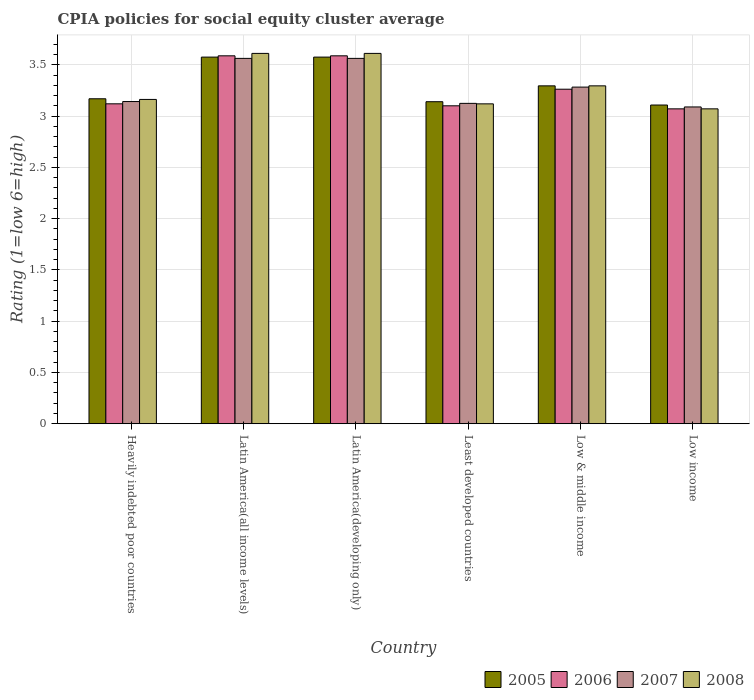How many groups of bars are there?
Keep it short and to the point. 6. Are the number of bars per tick equal to the number of legend labels?
Your answer should be compact. Yes. Are the number of bars on each tick of the X-axis equal?
Offer a very short reply. Yes. How many bars are there on the 5th tick from the right?
Offer a terse response. 4. What is the label of the 1st group of bars from the left?
Your answer should be very brief. Heavily indebted poor countries. What is the CPIA rating in 2006 in Latin America(developing only)?
Ensure brevity in your answer.  3.59. Across all countries, what is the maximum CPIA rating in 2005?
Give a very brief answer. 3.58. Across all countries, what is the minimum CPIA rating in 2007?
Make the answer very short. 3.09. In which country was the CPIA rating in 2005 maximum?
Keep it short and to the point. Latin America(all income levels). In which country was the CPIA rating in 2007 minimum?
Give a very brief answer. Low income. What is the total CPIA rating in 2008 in the graph?
Your response must be concise. 19.87. What is the difference between the CPIA rating in 2006 in Latin America(developing only) and that in Low income?
Keep it short and to the point. 0.52. What is the difference between the CPIA rating in 2008 in Least developed countries and the CPIA rating in 2007 in Low income?
Make the answer very short. 0.03. What is the average CPIA rating in 2005 per country?
Ensure brevity in your answer.  3.31. What is the difference between the CPIA rating of/in 2008 and CPIA rating of/in 2006 in Low income?
Offer a terse response. 0. In how many countries, is the CPIA rating in 2006 greater than 3.3?
Provide a succinct answer. 2. What is the ratio of the CPIA rating in 2007 in Latin America(developing only) to that in Low income?
Provide a short and direct response. 1.15. Is the CPIA rating in 2005 in Latin America(all income levels) less than that in Least developed countries?
Offer a very short reply. No. What is the difference between the highest and the second highest CPIA rating in 2006?
Offer a terse response. -0.33. What is the difference between the highest and the lowest CPIA rating in 2008?
Provide a succinct answer. 0.54. In how many countries, is the CPIA rating in 2008 greater than the average CPIA rating in 2008 taken over all countries?
Provide a short and direct response. 2. What does the 4th bar from the left in Heavily indebted poor countries represents?
Offer a very short reply. 2008. What does the 1st bar from the right in Latin America(developing only) represents?
Provide a succinct answer. 2008. Is it the case that in every country, the sum of the CPIA rating in 2006 and CPIA rating in 2008 is greater than the CPIA rating in 2007?
Your answer should be compact. Yes. How many bars are there?
Give a very brief answer. 24. How many countries are there in the graph?
Make the answer very short. 6. Are the values on the major ticks of Y-axis written in scientific E-notation?
Make the answer very short. No. Does the graph contain any zero values?
Provide a succinct answer. No. How many legend labels are there?
Offer a terse response. 4. What is the title of the graph?
Provide a succinct answer. CPIA policies for social equity cluster average. What is the label or title of the X-axis?
Ensure brevity in your answer.  Country. What is the Rating (1=low 6=high) in 2005 in Heavily indebted poor countries?
Keep it short and to the point. 3.17. What is the Rating (1=low 6=high) of 2006 in Heavily indebted poor countries?
Ensure brevity in your answer.  3.12. What is the Rating (1=low 6=high) of 2007 in Heavily indebted poor countries?
Make the answer very short. 3.14. What is the Rating (1=low 6=high) of 2008 in Heavily indebted poor countries?
Offer a very short reply. 3.16. What is the Rating (1=low 6=high) in 2005 in Latin America(all income levels)?
Your response must be concise. 3.58. What is the Rating (1=low 6=high) in 2006 in Latin America(all income levels)?
Provide a succinct answer. 3.59. What is the Rating (1=low 6=high) of 2007 in Latin America(all income levels)?
Your answer should be compact. 3.56. What is the Rating (1=low 6=high) of 2008 in Latin America(all income levels)?
Your response must be concise. 3.61. What is the Rating (1=low 6=high) of 2005 in Latin America(developing only)?
Provide a succinct answer. 3.58. What is the Rating (1=low 6=high) in 2006 in Latin America(developing only)?
Give a very brief answer. 3.59. What is the Rating (1=low 6=high) in 2007 in Latin America(developing only)?
Make the answer very short. 3.56. What is the Rating (1=low 6=high) in 2008 in Latin America(developing only)?
Offer a terse response. 3.61. What is the Rating (1=low 6=high) of 2005 in Least developed countries?
Provide a short and direct response. 3.14. What is the Rating (1=low 6=high) of 2006 in Least developed countries?
Provide a short and direct response. 3.1. What is the Rating (1=low 6=high) of 2007 in Least developed countries?
Your answer should be compact. 3.12. What is the Rating (1=low 6=high) of 2008 in Least developed countries?
Your answer should be compact. 3.12. What is the Rating (1=low 6=high) of 2005 in Low & middle income?
Your answer should be very brief. 3.29. What is the Rating (1=low 6=high) of 2006 in Low & middle income?
Give a very brief answer. 3.26. What is the Rating (1=low 6=high) in 2007 in Low & middle income?
Give a very brief answer. 3.28. What is the Rating (1=low 6=high) of 2008 in Low & middle income?
Keep it short and to the point. 3.29. What is the Rating (1=low 6=high) in 2005 in Low income?
Keep it short and to the point. 3.11. What is the Rating (1=low 6=high) of 2006 in Low income?
Provide a succinct answer. 3.07. What is the Rating (1=low 6=high) of 2007 in Low income?
Provide a succinct answer. 3.09. What is the Rating (1=low 6=high) in 2008 in Low income?
Make the answer very short. 3.07. Across all countries, what is the maximum Rating (1=low 6=high) in 2005?
Keep it short and to the point. 3.58. Across all countries, what is the maximum Rating (1=low 6=high) in 2006?
Keep it short and to the point. 3.59. Across all countries, what is the maximum Rating (1=low 6=high) in 2007?
Give a very brief answer. 3.56. Across all countries, what is the maximum Rating (1=low 6=high) of 2008?
Provide a succinct answer. 3.61. Across all countries, what is the minimum Rating (1=low 6=high) of 2005?
Your response must be concise. 3.11. Across all countries, what is the minimum Rating (1=low 6=high) in 2006?
Offer a very short reply. 3.07. Across all countries, what is the minimum Rating (1=low 6=high) in 2007?
Give a very brief answer. 3.09. Across all countries, what is the minimum Rating (1=low 6=high) of 2008?
Give a very brief answer. 3.07. What is the total Rating (1=low 6=high) in 2005 in the graph?
Your answer should be compact. 19.86. What is the total Rating (1=low 6=high) in 2006 in the graph?
Provide a succinct answer. 19.73. What is the total Rating (1=low 6=high) of 2007 in the graph?
Your answer should be compact. 19.76. What is the total Rating (1=low 6=high) in 2008 in the graph?
Your answer should be very brief. 19.87. What is the difference between the Rating (1=low 6=high) of 2005 in Heavily indebted poor countries and that in Latin America(all income levels)?
Ensure brevity in your answer.  -0.41. What is the difference between the Rating (1=low 6=high) of 2006 in Heavily indebted poor countries and that in Latin America(all income levels)?
Your response must be concise. -0.47. What is the difference between the Rating (1=low 6=high) in 2007 in Heavily indebted poor countries and that in Latin America(all income levels)?
Your answer should be compact. -0.42. What is the difference between the Rating (1=low 6=high) in 2008 in Heavily indebted poor countries and that in Latin America(all income levels)?
Give a very brief answer. -0.45. What is the difference between the Rating (1=low 6=high) of 2005 in Heavily indebted poor countries and that in Latin America(developing only)?
Make the answer very short. -0.41. What is the difference between the Rating (1=low 6=high) in 2006 in Heavily indebted poor countries and that in Latin America(developing only)?
Your answer should be compact. -0.47. What is the difference between the Rating (1=low 6=high) of 2007 in Heavily indebted poor countries and that in Latin America(developing only)?
Your answer should be very brief. -0.42. What is the difference between the Rating (1=low 6=high) of 2008 in Heavily indebted poor countries and that in Latin America(developing only)?
Your response must be concise. -0.45. What is the difference between the Rating (1=low 6=high) in 2005 in Heavily indebted poor countries and that in Least developed countries?
Provide a short and direct response. 0.03. What is the difference between the Rating (1=low 6=high) in 2006 in Heavily indebted poor countries and that in Least developed countries?
Provide a succinct answer. 0.02. What is the difference between the Rating (1=low 6=high) in 2007 in Heavily indebted poor countries and that in Least developed countries?
Keep it short and to the point. 0.02. What is the difference between the Rating (1=low 6=high) in 2008 in Heavily indebted poor countries and that in Least developed countries?
Provide a succinct answer. 0.04. What is the difference between the Rating (1=low 6=high) in 2005 in Heavily indebted poor countries and that in Low & middle income?
Give a very brief answer. -0.13. What is the difference between the Rating (1=low 6=high) of 2006 in Heavily indebted poor countries and that in Low & middle income?
Make the answer very short. -0.14. What is the difference between the Rating (1=low 6=high) in 2007 in Heavily indebted poor countries and that in Low & middle income?
Your answer should be very brief. -0.14. What is the difference between the Rating (1=low 6=high) of 2008 in Heavily indebted poor countries and that in Low & middle income?
Give a very brief answer. -0.13. What is the difference between the Rating (1=low 6=high) in 2005 in Heavily indebted poor countries and that in Low income?
Your response must be concise. 0.06. What is the difference between the Rating (1=low 6=high) of 2006 in Heavily indebted poor countries and that in Low income?
Make the answer very short. 0.05. What is the difference between the Rating (1=low 6=high) in 2007 in Heavily indebted poor countries and that in Low income?
Provide a succinct answer. 0.05. What is the difference between the Rating (1=low 6=high) of 2008 in Heavily indebted poor countries and that in Low income?
Keep it short and to the point. 0.09. What is the difference between the Rating (1=low 6=high) of 2005 in Latin America(all income levels) and that in Latin America(developing only)?
Provide a short and direct response. 0. What is the difference between the Rating (1=low 6=high) in 2005 in Latin America(all income levels) and that in Least developed countries?
Give a very brief answer. 0.43. What is the difference between the Rating (1=low 6=high) of 2006 in Latin America(all income levels) and that in Least developed countries?
Your answer should be very brief. 0.49. What is the difference between the Rating (1=low 6=high) in 2007 in Latin America(all income levels) and that in Least developed countries?
Your response must be concise. 0.44. What is the difference between the Rating (1=low 6=high) of 2008 in Latin America(all income levels) and that in Least developed countries?
Make the answer very short. 0.49. What is the difference between the Rating (1=low 6=high) of 2005 in Latin America(all income levels) and that in Low & middle income?
Provide a short and direct response. 0.28. What is the difference between the Rating (1=low 6=high) in 2006 in Latin America(all income levels) and that in Low & middle income?
Provide a succinct answer. 0.33. What is the difference between the Rating (1=low 6=high) of 2007 in Latin America(all income levels) and that in Low & middle income?
Your answer should be very brief. 0.28. What is the difference between the Rating (1=low 6=high) in 2008 in Latin America(all income levels) and that in Low & middle income?
Provide a succinct answer. 0.32. What is the difference between the Rating (1=low 6=high) of 2005 in Latin America(all income levels) and that in Low income?
Offer a very short reply. 0.47. What is the difference between the Rating (1=low 6=high) of 2006 in Latin America(all income levels) and that in Low income?
Give a very brief answer. 0.52. What is the difference between the Rating (1=low 6=high) of 2007 in Latin America(all income levels) and that in Low income?
Your answer should be very brief. 0.47. What is the difference between the Rating (1=low 6=high) in 2008 in Latin America(all income levels) and that in Low income?
Offer a very short reply. 0.54. What is the difference between the Rating (1=low 6=high) of 2005 in Latin America(developing only) and that in Least developed countries?
Offer a very short reply. 0.43. What is the difference between the Rating (1=low 6=high) in 2006 in Latin America(developing only) and that in Least developed countries?
Your response must be concise. 0.49. What is the difference between the Rating (1=low 6=high) of 2007 in Latin America(developing only) and that in Least developed countries?
Keep it short and to the point. 0.44. What is the difference between the Rating (1=low 6=high) in 2008 in Latin America(developing only) and that in Least developed countries?
Offer a very short reply. 0.49. What is the difference between the Rating (1=low 6=high) in 2005 in Latin America(developing only) and that in Low & middle income?
Provide a short and direct response. 0.28. What is the difference between the Rating (1=low 6=high) in 2006 in Latin America(developing only) and that in Low & middle income?
Give a very brief answer. 0.33. What is the difference between the Rating (1=low 6=high) in 2007 in Latin America(developing only) and that in Low & middle income?
Give a very brief answer. 0.28. What is the difference between the Rating (1=low 6=high) in 2008 in Latin America(developing only) and that in Low & middle income?
Your response must be concise. 0.32. What is the difference between the Rating (1=low 6=high) of 2005 in Latin America(developing only) and that in Low income?
Provide a succinct answer. 0.47. What is the difference between the Rating (1=low 6=high) of 2006 in Latin America(developing only) and that in Low income?
Your response must be concise. 0.52. What is the difference between the Rating (1=low 6=high) of 2007 in Latin America(developing only) and that in Low income?
Ensure brevity in your answer.  0.47. What is the difference between the Rating (1=low 6=high) in 2008 in Latin America(developing only) and that in Low income?
Provide a succinct answer. 0.54. What is the difference between the Rating (1=low 6=high) of 2005 in Least developed countries and that in Low & middle income?
Your response must be concise. -0.15. What is the difference between the Rating (1=low 6=high) of 2006 in Least developed countries and that in Low & middle income?
Your answer should be compact. -0.16. What is the difference between the Rating (1=low 6=high) in 2007 in Least developed countries and that in Low & middle income?
Provide a succinct answer. -0.16. What is the difference between the Rating (1=low 6=high) in 2008 in Least developed countries and that in Low & middle income?
Give a very brief answer. -0.18. What is the difference between the Rating (1=low 6=high) of 2005 in Least developed countries and that in Low income?
Offer a terse response. 0.03. What is the difference between the Rating (1=low 6=high) of 2006 in Least developed countries and that in Low income?
Keep it short and to the point. 0.03. What is the difference between the Rating (1=low 6=high) of 2007 in Least developed countries and that in Low income?
Your response must be concise. 0.03. What is the difference between the Rating (1=low 6=high) in 2008 in Least developed countries and that in Low income?
Your answer should be very brief. 0.05. What is the difference between the Rating (1=low 6=high) of 2005 in Low & middle income and that in Low income?
Offer a terse response. 0.19. What is the difference between the Rating (1=low 6=high) in 2006 in Low & middle income and that in Low income?
Provide a succinct answer. 0.19. What is the difference between the Rating (1=low 6=high) in 2007 in Low & middle income and that in Low income?
Make the answer very short. 0.19. What is the difference between the Rating (1=low 6=high) of 2008 in Low & middle income and that in Low income?
Make the answer very short. 0.22. What is the difference between the Rating (1=low 6=high) in 2005 in Heavily indebted poor countries and the Rating (1=low 6=high) in 2006 in Latin America(all income levels)?
Your answer should be compact. -0.42. What is the difference between the Rating (1=low 6=high) in 2005 in Heavily indebted poor countries and the Rating (1=low 6=high) in 2007 in Latin America(all income levels)?
Your response must be concise. -0.39. What is the difference between the Rating (1=low 6=high) of 2005 in Heavily indebted poor countries and the Rating (1=low 6=high) of 2008 in Latin America(all income levels)?
Your answer should be compact. -0.44. What is the difference between the Rating (1=low 6=high) in 2006 in Heavily indebted poor countries and the Rating (1=low 6=high) in 2007 in Latin America(all income levels)?
Give a very brief answer. -0.44. What is the difference between the Rating (1=low 6=high) in 2006 in Heavily indebted poor countries and the Rating (1=low 6=high) in 2008 in Latin America(all income levels)?
Give a very brief answer. -0.49. What is the difference between the Rating (1=low 6=high) in 2007 in Heavily indebted poor countries and the Rating (1=low 6=high) in 2008 in Latin America(all income levels)?
Ensure brevity in your answer.  -0.47. What is the difference between the Rating (1=low 6=high) in 2005 in Heavily indebted poor countries and the Rating (1=low 6=high) in 2006 in Latin America(developing only)?
Offer a very short reply. -0.42. What is the difference between the Rating (1=low 6=high) of 2005 in Heavily indebted poor countries and the Rating (1=low 6=high) of 2007 in Latin America(developing only)?
Give a very brief answer. -0.39. What is the difference between the Rating (1=low 6=high) of 2005 in Heavily indebted poor countries and the Rating (1=low 6=high) of 2008 in Latin America(developing only)?
Keep it short and to the point. -0.44. What is the difference between the Rating (1=low 6=high) of 2006 in Heavily indebted poor countries and the Rating (1=low 6=high) of 2007 in Latin America(developing only)?
Offer a very short reply. -0.44. What is the difference between the Rating (1=low 6=high) of 2006 in Heavily indebted poor countries and the Rating (1=low 6=high) of 2008 in Latin America(developing only)?
Ensure brevity in your answer.  -0.49. What is the difference between the Rating (1=low 6=high) in 2007 in Heavily indebted poor countries and the Rating (1=low 6=high) in 2008 in Latin America(developing only)?
Keep it short and to the point. -0.47. What is the difference between the Rating (1=low 6=high) in 2005 in Heavily indebted poor countries and the Rating (1=low 6=high) in 2006 in Least developed countries?
Provide a succinct answer. 0.07. What is the difference between the Rating (1=low 6=high) in 2005 in Heavily indebted poor countries and the Rating (1=low 6=high) in 2007 in Least developed countries?
Make the answer very short. 0.04. What is the difference between the Rating (1=low 6=high) in 2005 in Heavily indebted poor countries and the Rating (1=low 6=high) in 2008 in Least developed countries?
Provide a succinct answer. 0.05. What is the difference between the Rating (1=low 6=high) of 2006 in Heavily indebted poor countries and the Rating (1=low 6=high) of 2007 in Least developed countries?
Ensure brevity in your answer.  -0. What is the difference between the Rating (1=low 6=high) in 2006 in Heavily indebted poor countries and the Rating (1=low 6=high) in 2008 in Least developed countries?
Your answer should be compact. 0. What is the difference between the Rating (1=low 6=high) in 2007 in Heavily indebted poor countries and the Rating (1=low 6=high) in 2008 in Least developed countries?
Make the answer very short. 0.02. What is the difference between the Rating (1=low 6=high) in 2005 in Heavily indebted poor countries and the Rating (1=low 6=high) in 2006 in Low & middle income?
Offer a very short reply. -0.09. What is the difference between the Rating (1=low 6=high) in 2005 in Heavily indebted poor countries and the Rating (1=low 6=high) in 2007 in Low & middle income?
Give a very brief answer. -0.11. What is the difference between the Rating (1=low 6=high) of 2005 in Heavily indebted poor countries and the Rating (1=low 6=high) of 2008 in Low & middle income?
Your answer should be compact. -0.13. What is the difference between the Rating (1=low 6=high) in 2006 in Heavily indebted poor countries and the Rating (1=low 6=high) in 2007 in Low & middle income?
Give a very brief answer. -0.16. What is the difference between the Rating (1=low 6=high) of 2006 in Heavily indebted poor countries and the Rating (1=low 6=high) of 2008 in Low & middle income?
Provide a succinct answer. -0.18. What is the difference between the Rating (1=low 6=high) in 2007 in Heavily indebted poor countries and the Rating (1=low 6=high) in 2008 in Low & middle income?
Make the answer very short. -0.15. What is the difference between the Rating (1=low 6=high) of 2005 in Heavily indebted poor countries and the Rating (1=low 6=high) of 2006 in Low income?
Your answer should be very brief. 0.1. What is the difference between the Rating (1=low 6=high) in 2005 in Heavily indebted poor countries and the Rating (1=low 6=high) in 2007 in Low income?
Your answer should be very brief. 0.08. What is the difference between the Rating (1=low 6=high) in 2005 in Heavily indebted poor countries and the Rating (1=low 6=high) in 2008 in Low income?
Your answer should be compact. 0.1. What is the difference between the Rating (1=low 6=high) of 2006 in Heavily indebted poor countries and the Rating (1=low 6=high) of 2007 in Low income?
Provide a succinct answer. 0.03. What is the difference between the Rating (1=low 6=high) of 2006 in Heavily indebted poor countries and the Rating (1=low 6=high) of 2008 in Low income?
Your answer should be compact. 0.05. What is the difference between the Rating (1=low 6=high) in 2007 in Heavily indebted poor countries and the Rating (1=low 6=high) in 2008 in Low income?
Your response must be concise. 0.07. What is the difference between the Rating (1=low 6=high) in 2005 in Latin America(all income levels) and the Rating (1=low 6=high) in 2006 in Latin America(developing only)?
Your response must be concise. -0.01. What is the difference between the Rating (1=low 6=high) of 2005 in Latin America(all income levels) and the Rating (1=low 6=high) of 2007 in Latin America(developing only)?
Offer a terse response. 0.01. What is the difference between the Rating (1=low 6=high) of 2005 in Latin America(all income levels) and the Rating (1=low 6=high) of 2008 in Latin America(developing only)?
Offer a very short reply. -0.04. What is the difference between the Rating (1=low 6=high) of 2006 in Latin America(all income levels) and the Rating (1=low 6=high) of 2007 in Latin America(developing only)?
Give a very brief answer. 0.03. What is the difference between the Rating (1=low 6=high) in 2006 in Latin America(all income levels) and the Rating (1=low 6=high) in 2008 in Latin America(developing only)?
Your answer should be very brief. -0.02. What is the difference between the Rating (1=low 6=high) of 2007 in Latin America(all income levels) and the Rating (1=low 6=high) of 2008 in Latin America(developing only)?
Ensure brevity in your answer.  -0.05. What is the difference between the Rating (1=low 6=high) of 2005 in Latin America(all income levels) and the Rating (1=low 6=high) of 2006 in Least developed countries?
Provide a short and direct response. 0.47. What is the difference between the Rating (1=low 6=high) in 2005 in Latin America(all income levels) and the Rating (1=low 6=high) in 2007 in Least developed countries?
Keep it short and to the point. 0.45. What is the difference between the Rating (1=low 6=high) of 2005 in Latin America(all income levels) and the Rating (1=low 6=high) of 2008 in Least developed countries?
Ensure brevity in your answer.  0.46. What is the difference between the Rating (1=low 6=high) of 2006 in Latin America(all income levels) and the Rating (1=low 6=high) of 2007 in Least developed countries?
Give a very brief answer. 0.46. What is the difference between the Rating (1=low 6=high) in 2006 in Latin America(all income levels) and the Rating (1=low 6=high) in 2008 in Least developed countries?
Provide a succinct answer. 0.47. What is the difference between the Rating (1=low 6=high) in 2007 in Latin America(all income levels) and the Rating (1=low 6=high) in 2008 in Least developed countries?
Keep it short and to the point. 0.44. What is the difference between the Rating (1=low 6=high) of 2005 in Latin America(all income levels) and the Rating (1=low 6=high) of 2006 in Low & middle income?
Your answer should be very brief. 0.31. What is the difference between the Rating (1=low 6=high) in 2005 in Latin America(all income levels) and the Rating (1=low 6=high) in 2007 in Low & middle income?
Ensure brevity in your answer.  0.29. What is the difference between the Rating (1=low 6=high) in 2005 in Latin America(all income levels) and the Rating (1=low 6=high) in 2008 in Low & middle income?
Offer a terse response. 0.28. What is the difference between the Rating (1=low 6=high) in 2006 in Latin America(all income levels) and the Rating (1=low 6=high) in 2007 in Low & middle income?
Make the answer very short. 0.31. What is the difference between the Rating (1=low 6=high) of 2006 in Latin America(all income levels) and the Rating (1=low 6=high) of 2008 in Low & middle income?
Ensure brevity in your answer.  0.29. What is the difference between the Rating (1=low 6=high) of 2007 in Latin America(all income levels) and the Rating (1=low 6=high) of 2008 in Low & middle income?
Ensure brevity in your answer.  0.27. What is the difference between the Rating (1=low 6=high) in 2005 in Latin America(all income levels) and the Rating (1=low 6=high) in 2006 in Low income?
Offer a very short reply. 0.5. What is the difference between the Rating (1=low 6=high) in 2005 in Latin America(all income levels) and the Rating (1=low 6=high) in 2007 in Low income?
Your answer should be very brief. 0.49. What is the difference between the Rating (1=low 6=high) of 2005 in Latin America(all income levels) and the Rating (1=low 6=high) of 2008 in Low income?
Your answer should be compact. 0.5. What is the difference between the Rating (1=low 6=high) of 2006 in Latin America(all income levels) and the Rating (1=low 6=high) of 2007 in Low income?
Offer a very short reply. 0.5. What is the difference between the Rating (1=low 6=high) of 2006 in Latin America(all income levels) and the Rating (1=low 6=high) of 2008 in Low income?
Your response must be concise. 0.52. What is the difference between the Rating (1=low 6=high) of 2007 in Latin America(all income levels) and the Rating (1=low 6=high) of 2008 in Low income?
Provide a succinct answer. 0.49. What is the difference between the Rating (1=low 6=high) of 2005 in Latin America(developing only) and the Rating (1=low 6=high) of 2006 in Least developed countries?
Provide a succinct answer. 0.47. What is the difference between the Rating (1=low 6=high) of 2005 in Latin America(developing only) and the Rating (1=low 6=high) of 2007 in Least developed countries?
Provide a short and direct response. 0.45. What is the difference between the Rating (1=low 6=high) in 2005 in Latin America(developing only) and the Rating (1=low 6=high) in 2008 in Least developed countries?
Provide a short and direct response. 0.46. What is the difference between the Rating (1=low 6=high) of 2006 in Latin America(developing only) and the Rating (1=low 6=high) of 2007 in Least developed countries?
Make the answer very short. 0.46. What is the difference between the Rating (1=low 6=high) of 2006 in Latin America(developing only) and the Rating (1=low 6=high) of 2008 in Least developed countries?
Provide a short and direct response. 0.47. What is the difference between the Rating (1=low 6=high) in 2007 in Latin America(developing only) and the Rating (1=low 6=high) in 2008 in Least developed countries?
Offer a terse response. 0.44. What is the difference between the Rating (1=low 6=high) of 2005 in Latin America(developing only) and the Rating (1=low 6=high) of 2006 in Low & middle income?
Your answer should be compact. 0.31. What is the difference between the Rating (1=low 6=high) of 2005 in Latin America(developing only) and the Rating (1=low 6=high) of 2007 in Low & middle income?
Your response must be concise. 0.29. What is the difference between the Rating (1=low 6=high) in 2005 in Latin America(developing only) and the Rating (1=low 6=high) in 2008 in Low & middle income?
Give a very brief answer. 0.28. What is the difference between the Rating (1=low 6=high) in 2006 in Latin America(developing only) and the Rating (1=low 6=high) in 2007 in Low & middle income?
Give a very brief answer. 0.31. What is the difference between the Rating (1=low 6=high) in 2006 in Latin America(developing only) and the Rating (1=low 6=high) in 2008 in Low & middle income?
Your response must be concise. 0.29. What is the difference between the Rating (1=low 6=high) in 2007 in Latin America(developing only) and the Rating (1=low 6=high) in 2008 in Low & middle income?
Offer a terse response. 0.27. What is the difference between the Rating (1=low 6=high) of 2005 in Latin America(developing only) and the Rating (1=low 6=high) of 2006 in Low income?
Provide a short and direct response. 0.5. What is the difference between the Rating (1=low 6=high) of 2005 in Latin America(developing only) and the Rating (1=low 6=high) of 2007 in Low income?
Give a very brief answer. 0.49. What is the difference between the Rating (1=low 6=high) in 2005 in Latin America(developing only) and the Rating (1=low 6=high) in 2008 in Low income?
Offer a very short reply. 0.5. What is the difference between the Rating (1=low 6=high) of 2006 in Latin America(developing only) and the Rating (1=low 6=high) of 2007 in Low income?
Give a very brief answer. 0.5. What is the difference between the Rating (1=low 6=high) in 2006 in Latin America(developing only) and the Rating (1=low 6=high) in 2008 in Low income?
Provide a short and direct response. 0.52. What is the difference between the Rating (1=low 6=high) in 2007 in Latin America(developing only) and the Rating (1=low 6=high) in 2008 in Low income?
Provide a short and direct response. 0.49. What is the difference between the Rating (1=low 6=high) in 2005 in Least developed countries and the Rating (1=low 6=high) in 2006 in Low & middle income?
Your answer should be compact. -0.12. What is the difference between the Rating (1=low 6=high) in 2005 in Least developed countries and the Rating (1=low 6=high) in 2007 in Low & middle income?
Offer a very short reply. -0.14. What is the difference between the Rating (1=low 6=high) in 2005 in Least developed countries and the Rating (1=low 6=high) in 2008 in Low & middle income?
Give a very brief answer. -0.15. What is the difference between the Rating (1=low 6=high) of 2006 in Least developed countries and the Rating (1=low 6=high) of 2007 in Low & middle income?
Give a very brief answer. -0.18. What is the difference between the Rating (1=low 6=high) in 2006 in Least developed countries and the Rating (1=low 6=high) in 2008 in Low & middle income?
Offer a terse response. -0.19. What is the difference between the Rating (1=low 6=high) of 2007 in Least developed countries and the Rating (1=low 6=high) of 2008 in Low & middle income?
Give a very brief answer. -0.17. What is the difference between the Rating (1=low 6=high) in 2005 in Least developed countries and the Rating (1=low 6=high) in 2006 in Low income?
Offer a terse response. 0.07. What is the difference between the Rating (1=low 6=high) in 2005 in Least developed countries and the Rating (1=low 6=high) in 2007 in Low income?
Provide a short and direct response. 0.05. What is the difference between the Rating (1=low 6=high) of 2005 in Least developed countries and the Rating (1=low 6=high) of 2008 in Low income?
Offer a terse response. 0.07. What is the difference between the Rating (1=low 6=high) in 2006 in Least developed countries and the Rating (1=low 6=high) in 2007 in Low income?
Keep it short and to the point. 0.01. What is the difference between the Rating (1=low 6=high) in 2006 in Least developed countries and the Rating (1=low 6=high) in 2008 in Low income?
Your answer should be compact. 0.03. What is the difference between the Rating (1=low 6=high) in 2007 in Least developed countries and the Rating (1=low 6=high) in 2008 in Low income?
Offer a very short reply. 0.05. What is the difference between the Rating (1=low 6=high) of 2005 in Low & middle income and the Rating (1=low 6=high) of 2006 in Low income?
Your response must be concise. 0.22. What is the difference between the Rating (1=low 6=high) in 2005 in Low & middle income and the Rating (1=low 6=high) in 2007 in Low income?
Give a very brief answer. 0.21. What is the difference between the Rating (1=low 6=high) in 2005 in Low & middle income and the Rating (1=low 6=high) in 2008 in Low income?
Provide a succinct answer. 0.22. What is the difference between the Rating (1=low 6=high) in 2006 in Low & middle income and the Rating (1=low 6=high) in 2007 in Low income?
Make the answer very short. 0.17. What is the difference between the Rating (1=low 6=high) in 2006 in Low & middle income and the Rating (1=low 6=high) in 2008 in Low income?
Your answer should be compact. 0.19. What is the difference between the Rating (1=low 6=high) of 2007 in Low & middle income and the Rating (1=low 6=high) of 2008 in Low income?
Provide a succinct answer. 0.21. What is the average Rating (1=low 6=high) in 2005 per country?
Your answer should be very brief. 3.31. What is the average Rating (1=low 6=high) in 2006 per country?
Your answer should be very brief. 3.29. What is the average Rating (1=low 6=high) of 2007 per country?
Ensure brevity in your answer.  3.29. What is the average Rating (1=low 6=high) of 2008 per country?
Offer a terse response. 3.31. What is the difference between the Rating (1=low 6=high) in 2005 and Rating (1=low 6=high) in 2006 in Heavily indebted poor countries?
Your response must be concise. 0.05. What is the difference between the Rating (1=low 6=high) in 2005 and Rating (1=low 6=high) in 2007 in Heavily indebted poor countries?
Offer a terse response. 0.03. What is the difference between the Rating (1=low 6=high) in 2005 and Rating (1=low 6=high) in 2008 in Heavily indebted poor countries?
Ensure brevity in your answer.  0.01. What is the difference between the Rating (1=low 6=high) in 2006 and Rating (1=low 6=high) in 2007 in Heavily indebted poor countries?
Your answer should be compact. -0.02. What is the difference between the Rating (1=low 6=high) of 2006 and Rating (1=low 6=high) of 2008 in Heavily indebted poor countries?
Offer a terse response. -0.04. What is the difference between the Rating (1=low 6=high) in 2007 and Rating (1=low 6=high) in 2008 in Heavily indebted poor countries?
Your answer should be very brief. -0.02. What is the difference between the Rating (1=low 6=high) in 2005 and Rating (1=low 6=high) in 2006 in Latin America(all income levels)?
Give a very brief answer. -0.01. What is the difference between the Rating (1=low 6=high) of 2005 and Rating (1=low 6=high) of 2007 in Latin America(all income levels)?
Keep it short and to the point. 0.01. What is the difference between the Rating (1=low 6=high) in 2005 and Rating (1=low 6=high) in 2008 in Latin America(all income levels)?
Offer a terse response. -0.04. What is the difference between the Rating (1=low 6=high) of 2006 and Rating (1=low 6=high) of 2007 in Latin America(all income levels)?
Keep it short and to the point. 0.03. What is the difference between the Rating (1=low 6=high) of 2006 and Rating (1=low 6=high) of 2008 in Latin America(all income levels)?
Provide a succinct answer. -0.02. What is the difference between the Rating (1=low 6=high) in 2007 and Rating (1=low 6=high) in 2008 in Latin America(all income levels)?
Your answer should be very brief. -0.05. What is the difference between the Rating (1=low 6=high) of 2005 and Rating (1=low 6=high) of 2006 in Latin America(developing only)?
Provide a short and direct response. -0.01. What is the difference between the Rating (1=low 6=high) in 2005 and Rating (1=low 6=high) in 2007 in Latin America(developing only)?
Your response must be concise. 0.01. What is the difference between the Rating (1=low 6=high) of 2005 and Rating (1=low 6=high) of 2008 in Latin America(developing only)?
Offer a very short reply. -0.04. What is the difference between the Rating (1=low 6=high) in 2006 and Rating (1=low 6=high) in 2007 in Latin America(developing only)?
Your response must be concise. 0.03. What is the difference between the Rating (1=low 6=high) of 2006 and Rating (1=low 6=high) of 2008 in Latin America(developing only)?
Your answer should be compact. -0.02. What is the difference between the Rating (1=low 6=high) in 2007 and Rating (1=low 6=high) in 2008 in Latin America(developing only)?
Ensure brevity in your answer.  -0.05. What is the difference between the Rating (1=low 6=high) of 2005 and Rating (1=low 6=high) of 2007 in Least developed countries?
Offer a terse response. 0.02. What is the difference between the Rating (1=low 6=high) of 2005 and Rating (1=low 6=high) of 2008 in Least developed countries?
Provide a short and direct response. 0.02. What is the difference between the Rating (1=low 6=high) of 2006 and Rating (1=low 6=high) of 2007 in Least developed countries?
Your response must be concise. -0.02. What is the difference between the Rating (1=low 6=high) of 2006 and Rating (1=low 6=high) of 2008 in Least developed countries?
Offer a very short reply. -0.02. What is the difference between the Rating (1=low 6=high) of 2007 and Rating (1=low 6=high) of 2008 in Least developed countries?
Offer a very short reply. 0. What is the difference between the Rating (1=low 6=high) of 2005 and Rating (1=low 6=high) of 2006 in Low & middle income?
Your answer should be very brief. 0.03. What is the difference between the Rating (1=low 6=high) in 2005 and Rating (1=low 6=high) in 2007 in Low & middle income?
Ensure brevity in your answer.  0.01. What is the difference between the Rating (1=low 6=high) in 2005 and Rating (1=low 6=high) in 2008 in Low & middle income?
Offer a very short reply. -0. What is the difference between the Rating (1=low 6=high) in 2006 and Rating (1=low 6=high) in 2007 in Low & middle income?
Offer a terse response. -0.02. What is the difference between the Rating (1=low 6=high) in 2006 and Rating (1=low 6=high) in 2008 in Low & middle income?
Your response must be concise. -0.03. What is the difference between the Rating (1=low 6=high) of 2007 and Rating (1=low 6=high) of 2008 in Low & middle income?
Make the answer very short. -0.01. What is the difference between the Rating (1=low 6=high) of 2005 and Rating (1=low 6=high) of 2006 in Low income?
Your response must be concise. 0.04. What is the difference between the Rating (1=low 6=high) of 2005 and Rating (1=low 6=high) of 2007 in Low income?
Offer a terse response. 0.02. What is the difference between the Rating (1=low 6=high) of 2005 and Rating (1=low 6=high) of 2008 in Low income?
Your answer should be very brief. 0.04. What is the difference between the Rating (1=low 6=high) in 2006 and Rating (1=low 6=high) in 2007 in Low income?
Your answer should be very brief. -0.02. What is the difference between the Rating (1=low 6=high) of 2007 and Rating (1=low 6=high) of 2008 in Low income?
Your answer should be very brief. 0.02. What is the ratio of the Rating (1=low 6=high) of 2005 in Heavily indebted poor countries to that in Latin America(all income levels)?
Ensure brevity in your answer.  0.89. What is the ratio of the Rating (1=low 6=high) of 2006 in Heavily indebted poor countries to that in Latin America(all income levels)?
Keep it short and to the point. 0.87. What is the ratio of the Rating (1=low 6=high) in 2007 in Heavily indebted poor countries to that in Latin America(all income levels)?
Offer a very short reply. 0.88. What is the ratio of the Rating (1=low 6=high) of 2008 in Heavily indebted poor countries to that in Latin America(all income levels)?
Make the answer very short. 0.88. What is the ratio of the Rating (1=low 6=high) in 2005 in Heavily indebted poor countries to that in Latin America(developing only)?
Your response must be concise. 0.89. What is the ratio of the Rating (1=low 6=high) in 2006 in Heavily indebted poor countries to that in Latin America(developing only)?
Your response must be concise. 0.87. What is the ratio of the Rating (1=low 6=high) in 2007 in Heavily indebted poor countries to that in Latin America(developing only)?
Provide a succinct answer. 0.88. What is the ratio of the Rating (1=low 6=high) of 2008 in Heavily indebted poor countries to that in Latin America(developing only)?
Make the answer very short. 0.88. What is the ratio of the Rating (1=low 6=high) in 2005 in Heavily indebted poor countries to that in Least developed countries?
Your response must be concise. 1.01. What is the ratio of the Rating (1=low 6=high) in 2006 in Heavily indebted poor countries to that in Least developed countries?
Offer a terse response. 1.01. What is the ratio of the Rating (1=low 6=high) of 2007 in Heavily indebted poor countries to that in Least developed countries?
Ensure brevity in your answer.  1.01. What is the ratio of the Rating (1=low 6=high) in 2008 in Heavily indebted poor countries to that in Least developed countries?
Your answer should be compact. 1.01. What is the ratio of the Rating (1=low 6=high) in 2005 in Heavily indebted poor countries to that in Low & middle income?
Provide a short and direct response. 0.96. What is the ratio of the Rating (1=low 6=high) of 2006 in Heavily indebted poor countries to that in Low & middle income?
Give a very brief answer. 0.96. What is the ratio of the Rating (1=low 6=high) of 2007 in Heavily indebted poor countries to that in Low & middle income?
Keep it short and to the point. 0.96. What is the ratio of the Rating (1=low 6=high) of 2008 in Heavily indebted poor countries to that in Low & middle income?
Make the answer very short. 0.96. What is the ratio of the Rating (1=low 6=high) in 2005 in Heavily indebted poor countries to that in Low income?
Make the answer very short. 1.02. What is the ratio of the Rating (1=low 6=high) in 2007 in Heavily indebted poor countries to that in Low income?
Give a very brief answer. 1.02. What is the ratio of the Rating (1=low 6=high) of 2008 in Heavily indebted poor countries to that in Low income?
Your answer should be compact. 1.03. What is the ratio of the Rating (1=low 6=high) in 2005 in Latin America(all income levels) to that in Latin America(developing only)?
Provide a succinct answer. 1. What is the ratio of the Rating (1=low 6=high) in 2005 in Latin America(all income levels) to that in Least developed countries?
Offer a terse response. 1.14. What is the ratio of the Rating (1=low 6=high) of 2006 in Latin America(all income levels) to that in Least developed countries?
Your answer should be very brief. 1.16. What is the ratio of the Rating (1=low 6=high) in 2007 in Latin America(all income levels) to that in Least developed countries?
Keep it short and to the point. 1.14. What is the ratio of the Rating (1=low 6=high) of 2008 in Latin America(all income levels) to that in Least developed countries?
Provide a succinct answer. 1.16. What is the ratio of the Rating (1=low 6=high) in 2005 in Latin America(all income levels) to that in Low & middle income?
Your answer should be compact. 1.09. What is the ratio of the Rating (1=low 6=high) in 2006 in Latin America(all income levels) to that in Low & middle income?
Keep it short and to the point. 1.1. What is the ratio of the Rating (1=low 6=high) of 2007 in Latin America(all income levels) to that in Low & middle income?
Provide a short and direct response. 1.09. What is the ratio of the Rating (1=low 6=high) in 2008 in Latin America(all income levels) to that in Low & middle income?
Your answer should be compact. 1.1. What is the ratio of the Rating (1=low 6=high) of 2005 in Latin America(all income levels) to that in Low income?
Give a very brief answer. 1.15. What is the ratio of the Rating (1=low 6=high) of 2006 in Latin America(all income levels) to that in Low income?
Give a very brief answer. 1.17. What is the ratio of the Rating (1=low 6=high) in 2007 in Latin America(all income levels) to that in Low income?
Offer a very short reply. 1.15. What is the ratio of the Rating (1=low 6=high) in 2008 in Latin America(all income levels) to that in Low income?
Offer a terse response. 1.18. What is the ratio of the Rating (1=low 6=high) in 2005 in Latin America(developing only) to that in Least developed countries?
Provide a succinct answer. 1.14. What is the ratio of the Rating (1=low 6=high) of 2006 in Latin America(developing only) to that in Least developed countries?
Give a very brief answer. 1.16. What is the ratio of the Rating (1=low 6=high) of 2007 in Latin America(developing only) to that in Least developed countries?
Offer a very short reply. 1.14. What is the ratio of the Rating (1=low 6=high) in 2008 in Latin America(developing only) to that in Least developed countries?
Offer a very short reply. 1.16. What is the ratio of the Rating (1=low 6=high) in 2005 in Latin America(developing only) to that in Low & middle income?
Provide a succinct answer. 1.09. What is the ratio of the Rating (1=low 6=high) of 2006 in Latin America(developing only) to that in Low & middle income?
Give a very brief answer. 1.1. What is the ratio of the Rating (1=low 6=high) in 2007 in Latin America(developing only) to that in Low & middle income?
Offer a terse response. 1.09. What is the ratio of the Rating (1=low 6=high) of 2008 in Latin America(developing only) to that in Low & middle income?
Keep it short and to the point. 1.1. What is the ratio of the Rating (1=low 6=high) in 2005 in Latin America(developing only) to that in Low income?
Offer a terse response. 1.15. What is the ratio of the Rating (1=low 6=high) in 2006 in Latin America(developing only) to that in Low income?
Give a very brief answer. 1.17. What is the ratio of the Rating (1=low 6=high) in 2007 in Latin America(developing only) to that in Low income?
Offer a terse response. 1.15. What is the ratio of the Rating (1=low 6=high) of 2008 in Latin America(developing only) to that in Low income?
Provide a short and direct response. 1.18. What is the ratio of the Rating (1=low 6=high) of 2005 in Least developed countries to that in Low & middle income?
Give a very brief answer. 0.95. What is the ratio of the Rating (1=low 6=high) of 2006 in Least developed countries to that in Low & middle income?
Provide a short and direct response. 0.95. What is the ratio of the Rating (1=low 6=high) in 2007 in Least developed countries to that in Low & middle income?
Ensure brevity in your answer.  0.95. What is the ratio of the Rating (1=low 6=high) in 2008 in Least developed countries to that in Low & middle income?
Keep it short and to the point. 0.95. What is the ratio of the Rating (1=low 6=high) in 2005 in Least developed countries to that in Low income?
Ensure brevity in your answer.  1.01. What is the ratio of the Rating (1=low 6=high) of 2006 in Least developed countries to that in Low income?
Your answer should be compact. 1.01. What is the ratio of the Rating (1=low 6=high) of 2007 in Least developed countries to that in Low income?
Offer a very short reply. 1.01. What is the ratio of the Rating (1=low 6=high) of 2008 in Least developed countries to that in Low income?
Offer a terse response. 1.02. What is the ratio of the Rating (1=low 6=high) in 2005 in Low & middle income to that in Low income?
Provide a short and direct response. 1.06. What is the ratio of the Rating (1=low 6=high) of 2006 in Low & middle income to that in Low income?
Your answer should be very brief. 1.06. What is the ratio of the Rating (1=low 6=high) of 2007 in Low & middle income to that in Low income?
Keep it short and to the point. 1.06. What is the ratio of the Rating (1=low 6=high) of 2008 in Low & middle income to that in Low income?
Your response must be concise. 1.07. What is the difference between the highest and the second highest Rating (1=low 6=high) of 2006?
Keep it short and to the point. 0. What is the difference between the highest and the second highest Rating (1=low 6=high) in 2007?
Your answer should be very brief. 0. What is the difference between the highest and the second highest Rating (1=low 6=high) of 2008?
Offer a terse response. 0. What is the difference between the highest and the lowest Rating (1=low 6=high) in 2005?
Your answer should be very brief. 0.47. What is the difference between the highest and the lowest Rating (1=low 6=high) of 2006?
Your answer should be compact. 0.52. What is the difference between the highest and the lowest Rating (1=low 6=high) of 2007?
Provide a short and direct response. 0.47. What is the difference between the highest and the lowest Rating (1=low 6=high) of 2008?
Your response must be concise. 0.54. 